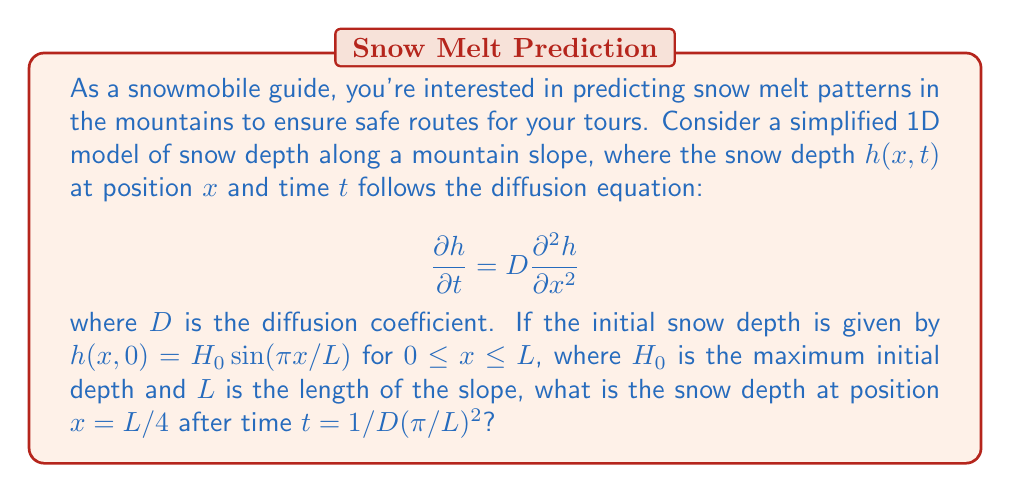Show me your answer to this math problem. To solve this problem, we need to use the solution to the diffusion equation with the given initial condition. The general solution for the 1D diffusion equation with sinusoidal initial conditions is:

$$h(x,t) = H_0 \sin(\frac{\pi x}{L}) e^{-D(\frac{\pi}{L})^2 t}$$

Now, let's follow these steps:

1) We're asked to find the snow depth at $x = L/4$ and $t = 1/D(\pi/L)^2$.

2) Substitute these values into the solution:

   $$h(L/4, 1/D(\pi/L)^2) = H_0 \sin(\frac{\pi (L/4)}{L}) e^{-D(\frac{\pi}{L})^2 \cdot \frac{1}{D(\pi/L)^2}}$$

3) Simplify the argument of the sine function:
   
   $$\sin(\frac{\pi (L/4)}{L}) = \sin(\frac{\pi}{4}) = \frac{\sqrt{2}}{2}$$

4) Simplify the exponent:

   $$e^{-D(\frac{\pi}{L})^2 \cdot \frac{1}{D(\pi/L)^2}} = e^{-1} = \frac{1}{e}$$

5) Putting it all together:

   $$h(L/4, 1/D(\pi/L)^2) = H_0 \cdot \frac{\sqrt{2}}{2} \cdot \frac{1}{e}$$

This gives us the final snow depth at the specified position and time.
Answer: $$h(L/4, 1/D(\pi/L)^2) = \frac{H_0\sqrt{2}}{2e}$$ 